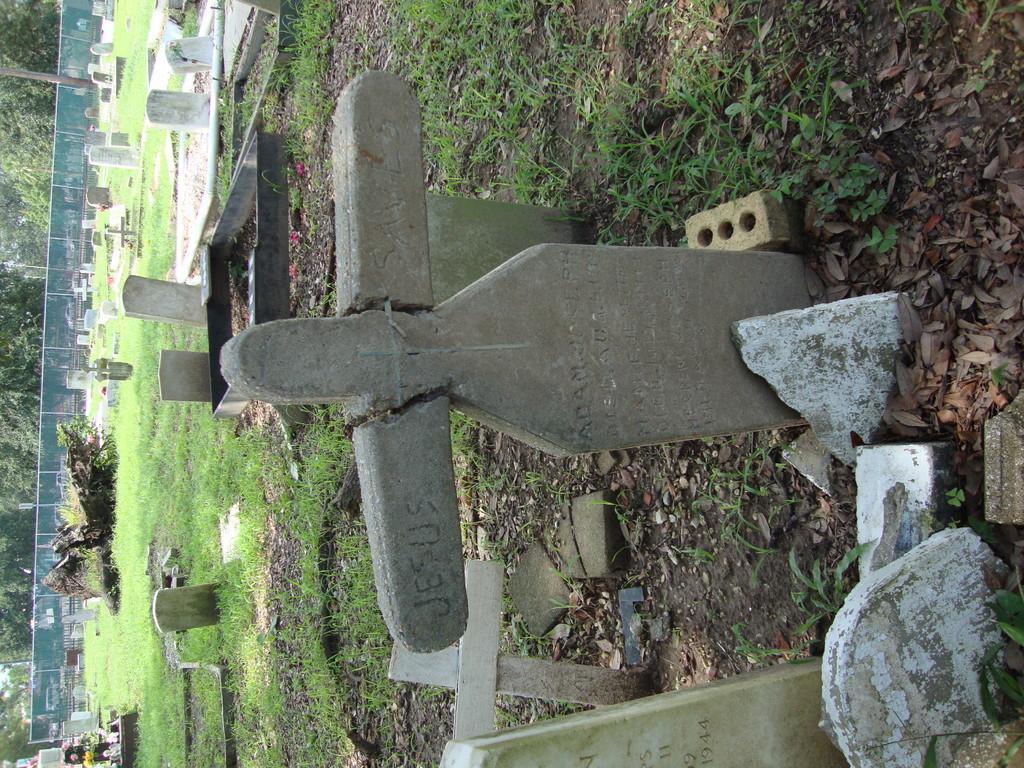In one or two sentences, can you explain what this image depicts? In the center of the image we can see gravestone, grass, dry leaves, stones are there. On the left side of the image we can see mesh, trees are present. 